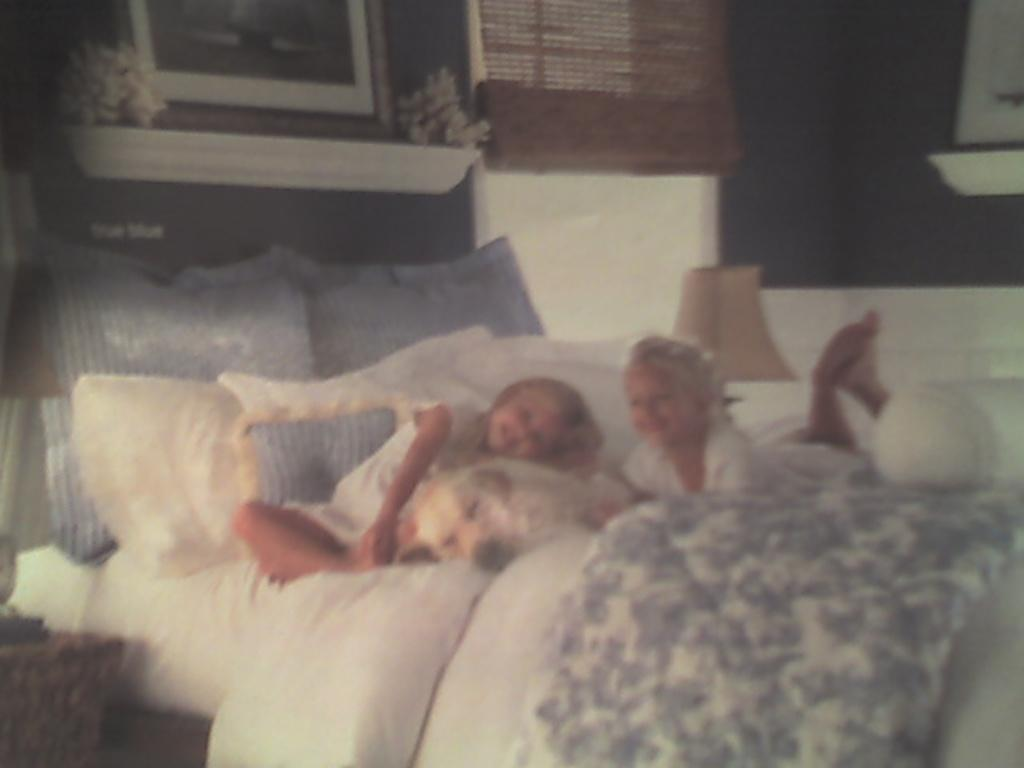How many children are lying on the bed in the image? There are two children lying on the bed in the image. What other living creature is present on the bed? A dog is present on the bed. What type of bedding is visible on the bed? There are blankets and pillows on the bed. What can be seen in the background of the image? There is a television and a wall in the background. What type of kettle is being used by the achiever in the image? There is no achiever or kettle present in the image. What is the chance of winning a prize in the image? There is no indication of a prize or a chance of winning in the image. 